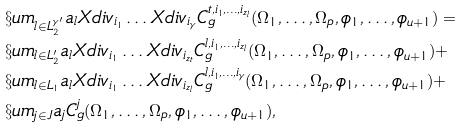<formula> <loc_0><loc_0><loc_500><loc_500>& \S u m _ { l \in L _ { 2 } ^ { \gamma ^ { \prime } } } a _ { l } X d i v _ { i _ { 1 } } \dots X d i v _ { i _ { \gamma } } C ^ { t , i _ { 1 } , \dots , i _ { z _ { l } } } _ { g } ( \Omega _ { 1 } , \dots , \Omega _ { p } , \phi _ { 1 } , \dots , \phi _ { u + 1 } ) = \\ & \S u m _ { l \in L _ { 2 } ^ { \prime } } a _ { l } X d i v _ { i _ { 1 } } \dots X d i v _ { i _ { z _ { t } } } C ^ { l , i _ { 1 } , \dots , i _ { z _ { l } } } _ { g } ( \Omega _ { 1 } , \dots , \Omega _ { p } , \phi _ { 1 } , \dots , \phi _ { u + 1 } ) + \\ & \S u m _ { l \in L _ { 1 } } a _ { l } X d i v _ { i _ { 1 } } \dots X d i v _ { i _ { z _ { l } } } C ^ { l , i _ { 1 } , \dots , i _ { \gamma } } _ { g } ( \Omega _ { 1 } , \dots , \Omega _ { p } , \phi _ { 1 } , \dots , \phi _ { u + 1 } ) + \\ & \S u m _ { j \in J } a _ { j } C ^ { j } _ { g } ( \Omega _ { 1 } , \dots , \Omega _ { p } , \phi _ { 1 } , \dots , \phi _ { u + 1 } ) ,</formula> 